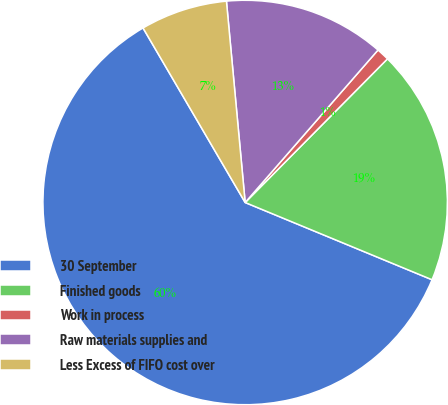Convert chart. <chart><loc_0><loc_0><loc_500><loc_500><pie_chart><fcel>30 September<fcel>Finished goods<fcel>Work in process<fcel>Raw materials supplies and<fcel>Less Excess of FIFO cost over<nl><fcel>60.33%<fcel>18.81%<fcel>1.02%<fcel>12.88%<fcel>6.95%<nl></chart> 